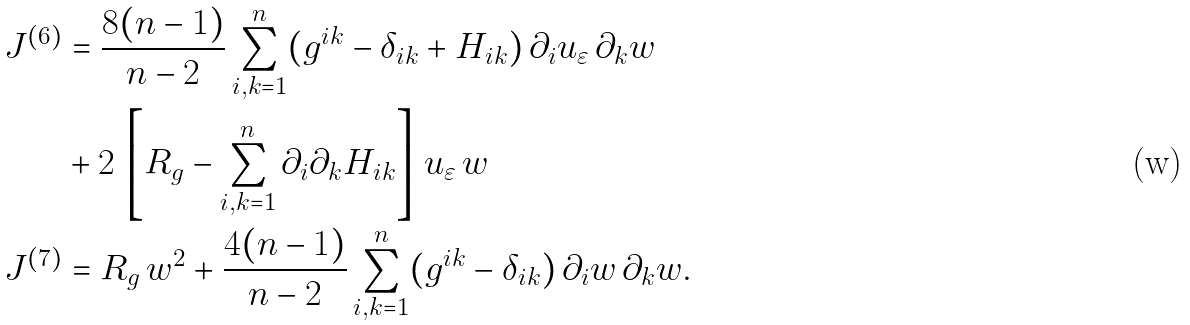<formula> <loc_0><loc_0><loc_500><loc_500>J ^ { ( 6 ) } & = \frac { 8 ( n - 1 ) } { n - 2 } \sum _ { i , k = 1 } ^ { n } ( g ^ { i k } - \delta _ { i k } + H _ { i k } ) \, \partial _ { i } u _ { \varepsilon } \, \partial _ { k } w \\ & + 2 \, \left [ R _ { g } - \sum _ { i , k = 1 } ^ { n } \partial _ { i } \partial _ { k } H _ { i k } \right ] \, u _ { \varepsilon } \, w \\ J ^ { ( 7 ) } & = R _ { g } \, w ^ { 2 } + \frac { 4 ( n - 1 ) } { n - 2 } \sum _ { i , k = 1 } ^ { n } ( g ^ { i k } - \delta _ { i k } ) \, \partial _ { i } w \, \partial _ { k } w .</formula> 